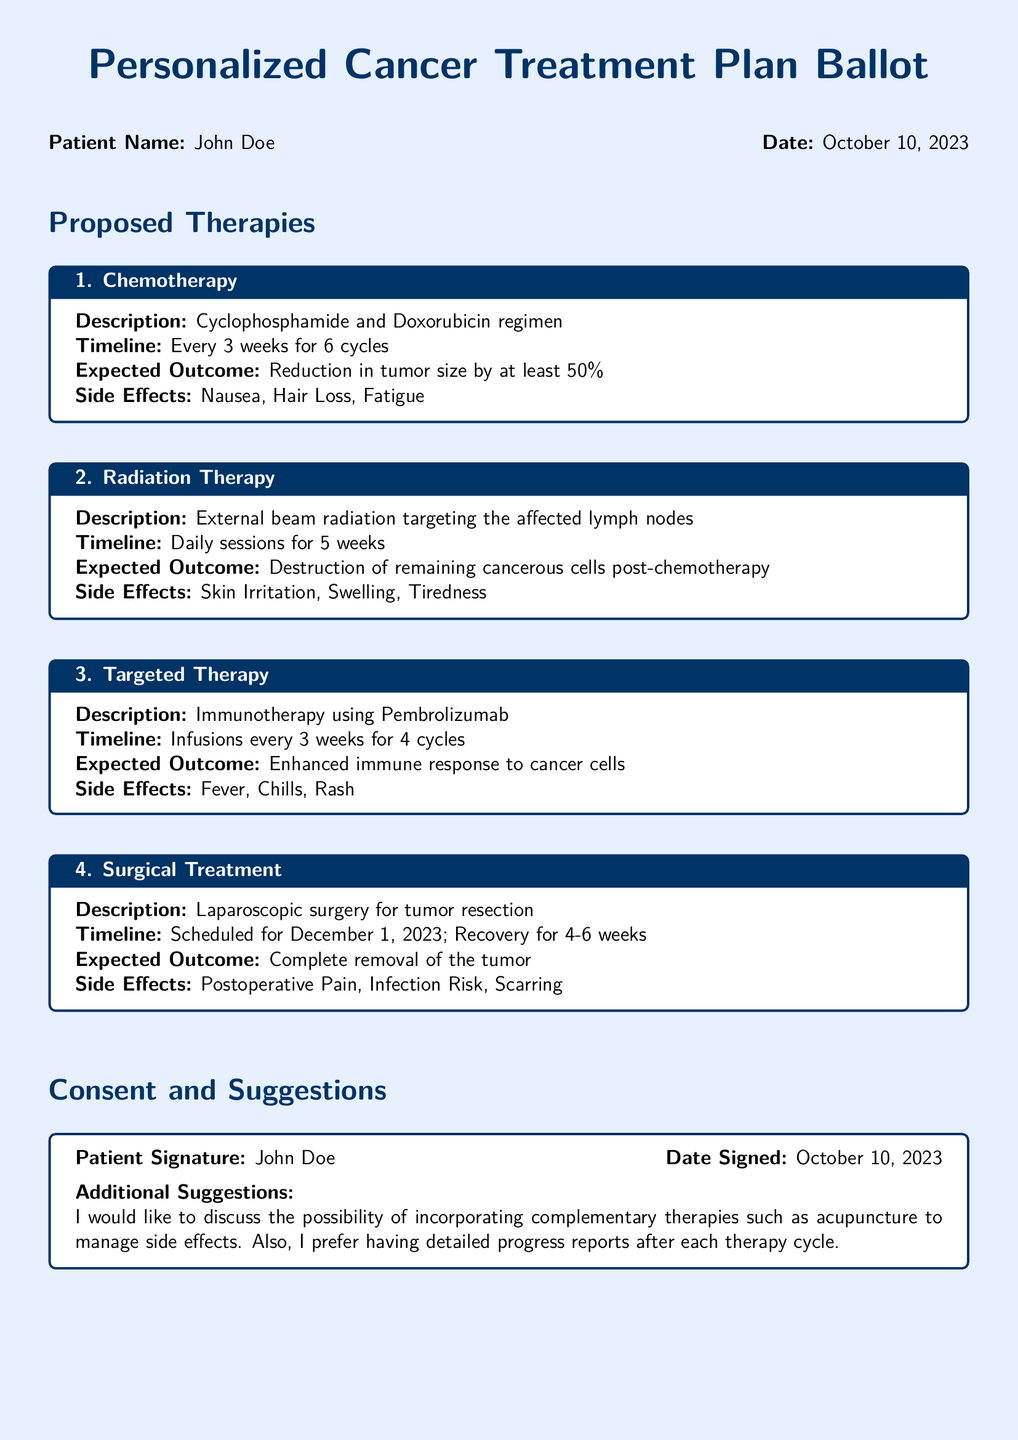What is the patient's name? The patient's name is mentioned in the document header as "John Doe."
Answer: John Doe What is the date of the treatment plan? The date is specified in the header of the document as "October 10, 2023."
Answer: October 10, 2023 How many cycles of chemotherapy are proposed? The document states that chemotherapy is proposed for "6 cycles."
Answer: 6 cycles What is the expected outcome of the targeted therapy? The expected outcome for targeted therapy is described as "Enhanced immune response to cancer cells."
Answer: Enhanced immune response to cancer cells What is the timeline for the surgical treatment? The document outlines that the surgery is scheduled for "December 1, 2023," with recovery for "4-6 weeks."
Answer: December 1, 2023; 4-6 weeks What side effect is associated with radiation therapy? One of the side effects listed for radiation therapy is "Skin Irritation."
Answer: Skin Irritation Who is the healthcare provider? The healthcare provider's name is given in the section titled "Healthcare Provider" as "Dr. Emily White."
Answer: Dr. Emily White What additional suggestion did the patient make? The patient mentioned that they would like to "discuss the possibility of incorporating complementary therapies."
Answer: Incorporating complementary therapies What institution is the healthcare provider associated with? The document specifies that the provider is from "City Cancer Clinic."
Answer: City Cancer Clinic 